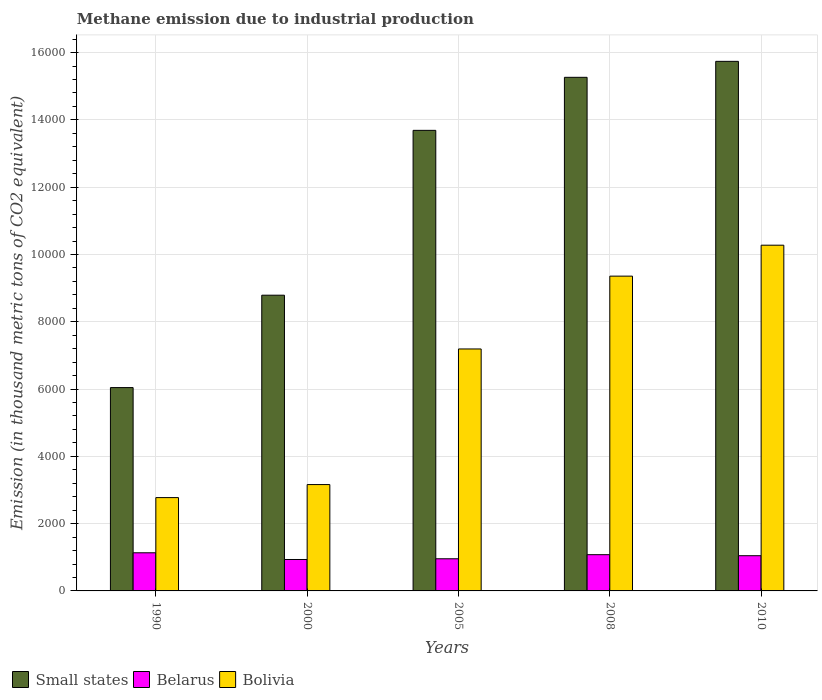How many groups of bars are there?
Give a very brief answer. 5. Are the number of bars per tick equal to the number of legend labels?
Your answer should be compact. Yes. Are the number of bars on each tick of the X-axis equal?
Your answer should be very brief. Yes. How many bars are there on the 2nd tick from the left?
Provide a succinct answer. 3. What is the label of the 1st group of bars from the left?
Offer a terse response. 1990. What is the amount of methane emitted in Belarus in 2010?
Offer a very short reply. 1046.7. Across all years, what is the maximum amount of methane emitted in Small states?
Provide a short and direct response. 1.57e+04. Across all years, what is the minimum amount of methane emitted in Small states?
Give a very brief answer. 6043.6. In which year was the amount of methane emitted in Belarus maximum?
Offer a terse response. 1990. In which year was the amount of methane emitted in Bolivia minimum?
Your answer should be compact. 1990. What is the total amount of methane emitted in Small states in the graph?
Your answer should be very brief. 5.95e+04. What is the difference between the amount of methane emitted in Bolivia in 2008 and that in 2010?
Offer a terse response. -919.7. What is the difference between the amount of methane emitted in Bolivia in 2008 and the amount of methane emitted in Belarus in 2000?
Your answer should be very brief. 8422.1. What is the average amount of methane emitted in Small states per year?
Give a very brief answer. 1.19e+04. In the year 2000, what is the difference between the amount of methane emitted in Small states and amount of methane emitted in Bolivia?
Offer a terse response. 5629.1. What is the ratio of the amount of methane emitted in Belarus in 1990 to that in 2010?
Make the answer very short. 1.08. Is the difference between the amount of methane emitted in Small states in 2005 and 2008 greater than the difference between the amount of methane emitted in Bolivia in 2005 and 2008?
Offer a terse response. Yes. What is the difference between the highest and the second highest amount of methane emitted in Small states?
Your answer should be compact. 474.8. What is the difference between the highest and the lowest amount of methane emitted in Small states?
Offer a very short reply. 9696.7. In how many years, is the amount of methane emitted in Belarus greater than the average amount of methane emitted in Belarus taken over all years?
Offer a terse response. 3. What does the 2nd bar from the left in 1990 represents?
Keep it short and to the point. Belarus. Is it the case that in every year, the sum of the amount of methane emitted in Belarus and amount of methane emitted in Small states is greater than the amount of methane emitted in Bolivia?
Offer a terse response. Yes. How many bars are there?
Make the answer very short. 15. What is the difference between two consecutive major ticks on the Y-axis?
Your answer should be compact. 2000. Does the graph contain grids?
Ensure brevity in your answer.  Yes. How are the legend labels stacked?
Make the answer very short. Horizontal. What is the title of the graph?
Keep it short and to the point. Methane emission due to industrial production. Does "Mexico" appear as one of the legend labels in the graph?
Offer a terse response. No. What is the label or title of the X-axis?
Ensure brevity in your answer.  Years. What is the label or title of the Y-axis?
Provide a short and direct response. Emission (in thousand metric tons of CO2 equivalent). What is the Emission (in thousand metric tons of CO2 equivalent) in Small states in 1990?
Provide a succinct answer. 6043.6. What is the Emission (in thousand metric tons of CO2 equivalent) of Belarus in 1990?
Offer a very short reply. 1133.2. What is the Emission (in thousand metric tons of CO2 equivalent) in Bolivia in 1990?
Keep it short and to the point. 2773.8. What is the Emission (in thousand metric tons of CO2 equivalent) in Small states in 2000?
Offer a terse response. 8790. What is the Emission (in thousand metric tons of CO2 equivalent) of Belarus in 2000?
Give a very brief answer. 934.2. What is the Emission (in thousand metric tons of CO2 equivalent) in Bolivia in 2000?
Offer a terse response. 3160.9. What is the Emission (in thousand metric tons of CO2 equivalent) of Small states in 2005?
Keep it short and to the point. 1.37e+04. What is the Emission (in thousand metric tons of CO2 equivalent) of Belarus in 2005?
Offer a terse response. 955.3. What is the Emission (in thousand metric tons of CO2 equivalent) of Bolivia in 2005?
Offer a very short reply. 7191.7. What is the Emission (in thousand metric tons of CO2 equivalent) in Small states in 2008?
Offer a very short reply. 1.53e+04. What is the Emission (in thousand metric tons of CO2 equivalent) in Belarus in 2008?
Offer a terse response. 1077.2. What is the Emission (in thousand metric tons of CO2 equivalent) of Bolivia in 2008?
Make the answer very short. 9356.3. What is the Emission (in thousand metric tons of CO2 equivalent) of Small states in 2010?
Make the answer very short. 1.57e+04. What is the Emission (in thousand metric tons of CO2 equivalent) of Belarus in 2010?
Keep it short and to the point. 1046.7. What is the Emission (in thousand metric tons of CO2 equivalent) of Bolivia in 2010?
Provide a succinct answer. 1.03e+04. Across all years, what is the maximum Emission (in thousand metric tons of CO2 equivalent) of Small states?
Offer a very short reply. 1.57e+04. Across all years, what is the maximum Emission (in thousand metric tons of CO2 equivalent) in Belarus?
Your response must be concise. 1133.2. Across all years, what is the maximum Emission (in thousand metric tons of CO2 equivalent) in Bolivia?
Your answer should be compact. 1.03e+04. Across all years, what is the minimum Emission (in thousand metric tons of CO2 equivalent) of Small states?
Offer a very short reply. 6043.6. Across all years, what is the minimum Emission (in thousand metric tons of CO2 equivalent) of Belarus?
Provide a succinct answer. 934.2. Across all years, what is the minimum Emission (in thousand metric tons of CO2 equivalent) of Bolivia?
Your answer should be very brief. 2773.8. What is the total Emission (in thousand metric tons of CO2 equivalent) in Small states in the graph?
Your answer should be compact. 5.95e+04. What is the total Emission (in thousand metric tons of CO2 equivalent) of Belarus in the graph?
Make the answer very short. 5146.6. What is the total Emission (in thousand metric tons of CO2 equivalent) in Bolivia in the graph?
Give a very brief answer. 3.28e+04. What is the difference between the Emission (in thousand metric tons of CO2 equivalent) of Small states in 1990 and that in 2000?
Your answer should be compact. -2746.4. What is the difference between the Emission (in thousand metric tons of CO2 equivalent) in Belarus in 1990 and that in 2000?
Make the answer very short. 199. What is the difference between the Emission (in thousand metric tons of CO2 equivalent) in Bolivia in 1990 and that in 2000?
Ensure brevity in your answer.  -387.1. What is the difference between the Emission (in thousand metric tons of CO2 equivalent) of Small states in 1990 and that in 2005?
Your response must be concise. -7645.8. What is the difference between the Emission (in thousand metric tons of CO2 equivalent) of Belarus in 1990 and that in 2005?
Keep it short and to the point. 177.9. What is the difference between the Emission (in thousand metric tons of CO2 equivalent) of Bolivia in 1990 and that in 2005?
Make the answer very short. -4417.9. What is the difference between the Emission (in thousand metric tons of CO2 equivalent) of Small states in 1990 and that in 2008?
Provide a short and direct response. -9221.9. What is the difference between the Emission (in thousand metric tons of CO2 equivalent) of Belarus in 1990 and that in 2008?
Provide a short and direct response. 56. What is the difference between the Emission (in thousand metric tons of CO2 equivalent) of Bolivia in 1990 and that in 2008?
Ensure brevity in your answer.  -6582.5. What is the difference between the Emission (in thousand metric tons of CO2 equivalent) in Small states in 1990 and that in 2010?
Your response must be concise. -9696.7. What is the difference between the Emission (in thousand metric tons of CO2 equivalent) of Belarus in 1990 and that in 2010?
Offer a very short reply. 86.5. What is the difference between the Emission (in thousand metric tons of CO2 equivalent) in Bolivia in 1990 and that in 2010?
Provide a succinct answer. -7502.2. What is the difference between the Emission (in thousand metric tons of CO2 equivalent) of Small states in 2000 and that in 2005?
Your answer should be very brief. -4899.4. What is the difference between the Emission (in thousand metric tons of CO2 equivalent) of Belarus in 2000 and that in 2005?
Provide a short and direct response. -21.1. What is the difference between the Emission (in thousand metric tons of CO2 equivalent) of Bolivia in 2000 and that in 2005?
Make the answer very short. -4030.8. What is the difference between the Emission (in thousand metric tons of CO2 equivalent) of Small states in 2000 and that in 2008?
Your response must be concise. -6475.5. What is the difference between the Emission (in thousand metric tons of CO2 equivalent) in Belarus in 2000 and that in 2008?
Keep it short and to the point. -143. What is the difference between the Emission (in thousand metric tons of CO2 equivalent) of Bolivia in 2000 and that in 2008?
Offer a very short reply. -6195.4. What is the difference between the Emission (in thousand metric tons of CO2 equivalent) of Small states in 2000 and that in 2010?
Your answer should be compact. -6950.3. What is the difference between the Emission (in thousand metric tons of CO2 equivalent) in Belarus in 2000 and that in 2010?
Offer a terse response. -112.5. What is the difference between the Emission (in thousand metric tons of CO2 equivalent) of Bolivia in 2000 and that in 2010?
Your answer should be very brief. -7115.1. What is the difference between the Emission (in thousand metric tons of CO2 equivalent) of Small states in 2005 and that in 2008?
Keep it short and to the point. -1576.1. What is the difference between the Emission (in thousand metric tons of CO2 equivalent) of Belarus in 2005 and that in 2008?
Provide a succinct answer. -121.9. What is the difference between the Emission (in thousand metric tons of CO2 equivalent) of Bolivia in 2005 and that in 2008?
Keep it short and to the point. -2164.6. What is the difference between the Emission (in thousand metric tons of CO2 equivalent) of Small states in 2005 and that in 2010?
Give a very brief answer. -2050.9. What is the difference between the Emission (in thousand metric tons of CO2 equivalent) of Belarus in 2005 and that in 2010?
Make the answer very short. -91.4. What is the difference between the Emission (in thousand metric tons of CO2 equivalent) in Bolivia in 2005 and that in 2010?
Keep it short and to the point. -3084.3. What is the difference between the Emission (in thousand metric tons of CO2 equivalent) of Small states in 2008 and that in 2010?
Offer a terse response. -474.8. What is the difference between the Emission (in thousand metric tons of CO2 equivalent) in Belarus in 2008 and that in 2010?
Provide a short and direct response. 30.5. What is the difference between the Emission (in thousand metric tons of CO2 equivalent) of Bolivia in 2008 and that in 2010?
Make the answer very short. -919.7. What is the difference between the Emission (in thousand metric tons of CO2 equivalent) of Small states in 1990 and the Emission (in thousand metric tons of CO2 equivalent) of Belarus in 2000?
Give a very brief answer. 5109.4. What is the difference between the Emission (in thousand metric tons of CO2 equivalent) of Small states in 1990 and the Emission (in thousand metric tons of CO2 equivalent) of Bolivia in 2000?
Provide a short and direct response. 2882.7. What is the difference between the Emission (in thousand metric tons of CO2 equivalent) in Belarus in 1990 and the Emission (in thousand metric tons of CO2 equivalent) in Bolivia in 2000?
Offer a terse response. -2027.7. What is the difference between the Emission (in thousand metric tons of CO2 equivalent) in Small states in 1990 and the Emission (in thousand metric tons of CO2 equivalent) in Belarus in 2005?
Your response must be concise. 5088.3. What is the difference between the Emission (in thousand metric tons of CO2 equivalent) of Small states in 1990 and the Emission (in thousand metric tons of CO2 equivalent) of Bolivia in 2005?
Keep it short and to the point. -1148.1. What is the difference between the Emission (in thousand metric tons of CO2 equivalent) of Belarus in 1990 and the Emission (in thousand metric tons of CO2 equivalent) of Bolivia in 2005?
Make the answer very short. -6058.5. What is the difference between the Emission (in thousand metric tons of CO2 equivalent) of Small states in 1990 and the Emission (in thousand metric tons of CO2 equivalent) of Belarus in 2008?
Provide a succinct answer. 4966.4. What is the difference between the Emission (in thousand metric tons of CO2 equivalent) in Small states in 1990 and the Emission (in thousand metric tons of CO2 equivalent) in Bolivia in 2008?
Ensure brevity in your answer.  -3312.7. What is the difference between the Emission (in thousand metric tons of CO2 equivalent) of Belarus in 1990 and the Emission (in thousand metric tons of CO2 equivalent) of Bolivia in 2008?
Give a very brief answer. -8223.1. What is the difference between the Emission (in thousand metric tons of CO2 equivalent) of Small states in 1990 and the Emission (in thousand metric tons of CO2 equivalent) of Belarus in 2010?
Provide a succinct answer. 4996.9. What is the difference between the Emission (in thousand metric tons of CO2 equivalent) of Small states in 1990 and the Emission (in thousand metric tons of CO2 equivalent) of Bolivia in 2010?
Your answer should be very brief. -4232.4. What is the difference between the Emission (in thousand metric tons of CO2 equivalent) of Belarus in 1990 and the Emission (in thousand metric tons of CO2 equivalent) of Bolivia in 2010?
Offer a very short reply. -9142.8. What is the difference between the Emission (in thousand metric tons of CO2 equivalent) of Small states in 2000 and the Emission (in thousand metric tons of CO2 equivalent) of Belarus in 2005?
Offer a very short reply. 7834.7. What is the difference between the Emission (in thousand metric tons of CO2 equivalent) of Small states in 2000 and the Emission (in thousand metric tons of CO2 equivalent) of Bolivia in 2005?
Provide a short and direct response. 1598.3. What is the difference between the Emission (in thousand metric tons of CO2 equivalent) of Belarus in 2000 and the Emission (in thousand metric tons of CO2 equivalent) of Bolivia in 2005?
Your answer should be compact. -6257.5. What is the difference between the Emission (in thousand metric tons of CO2 equivalent) in Small states in 2000 and the Emission (in thousand metric tons of CO2 equivalent) in Belarus in 2008?
Your answer should be very brief. 7712.8. What is the difference between the Emission (in thousand metric tons of CO2 equivalent) in Small states in 2000 and the Emission (in thousand metric tons of CO2 equivalent) in Bolivia in 2008?
Your response must be concise. -566.3. What is the difference between the Emission (in thousand metric tons of CO2 equivalent) in Belarus in 2000 and the Emission (in thousand metric tons of CO2 equivalent) in Bolivia in 2008?
Keep it short and to the point. -8422.1. What is the difference between the Emission (in thousand metric tons of CO2 equivalent) of Small states in 2000 and the Emission (in thousand metric tons of CO2 equivalent) of Belarus in 2010?
Give a very brief answer. 7743.3. What is the difference between the Emission (in thousand metric tons of CO2 equivalent) of Small states in 2000 and the Emission (in thousand metric tons of CO2 equivalent) of Bolivia in 2010?
Provide a short and direct response. -1486. What is the difference between the Emission (in thousand metric tons of CO2 equivalent) of Belarus in 2000 and the Emission (in thousand metric tons of CO2 equivalent) of Bolivia in 2010?
Keep it short and to the point. -9341.8. What is the difference between the Emission (in thousand metric tons of CO2 equivalent) of Small states in 2005 and the Emission (in thousand metric tons of CO2 equivalent) of Belarus in 2008?
Ensure brevity in your answer.  1.26e+04. What is the difference between the Emission (in thousand metric tons of CO2 equivalent) in Small states in 2005 and the Emission (in thousand metric tons of CO2 equivalent) in Bolivia in 2008?
Provide a succinct answer. 4333.1. What is the difference between the Emission (in thousand metric tons of CO2 equivalent) in Belarus in 2005 and the Emission (in thousand metric tons of CO2 equivalent) in Bolivia in 2008?
Provide a short and direct response. -8401. What is the difference between the Emission (in thousand metric tons of CO2 equivalent) of Small states in 2005 and the Emission (in thousand metric tons of CO2 equivalent) of Belarus in 2010?
Your response must be concise. 1.26e+04. What is the difference between the Emission (in thousand metric tons of CO2 equivalent) in Small states in 2005 and the Emission (in thousand metric tons of CO2 equivalent) in Bolivia in 2010?
Offer a very short reply. 3413.4. What is the difference between the Emission (in thousand metric tons of CO2 equivalent) of Belarus in 2005 and the Emission (in thousand metric tons of CO2 equivalent) of Bolivia in 2010?
Your response must be concise. -9320.7. What is the difference between the Emission (in thousand metric tons of CO2 equivalent) in Small states in 2008 and the Emission (in thousand metric tons of CO2 equivalent) in Belarus in 2010?
Provide a short and direct response. 1.42e+04. What is the difference between the Emission (in thousand metric tons of CO2 equivalent) of Small states in 2008 and the Emission (in thousand metric tons of CO2 equivalent) of Bolivia in 2010?
Give a very brief answer. 4989.5. What is the difference between the Emission (in thousand metric tons of CO2 equivalent) of Belarus in 2008 and the Emission (in thousand metric tons of CO2 equivalent) of Bolivia in 2010?
Your answer should be compact. -9198.8. What is the average Emission (in thousand metric tons of CO2 equivalent) in Small states per year?
Keep it short and to the point. 1.19e+04. What is the average Emission (in thousand metric tons of CO2 equivalent) in Belarus per year?
Offer a very short reply. 1029.32. What is the average Emission (in thousand metric tons of CO2 equivalent) of Bolivia per year?
Give a very brief answer. 6551.74. In the year 1990, what is the difference between the Emission (in thousand metric tons of CO2 equivalent) of Small states and Emission (in thousand metric tons of CO2 equivalent) of Belarus?
Your response must be concise. 4910.4. In the year 1990, what is the difference between the Emission (in thousand metric tons of CO2 equivalent) of Small states and Emission (in thousand metric tons of CO2 equivalent) of Bolivia?
Keep it short and to the point. 3269.8. In the year 1990, what is the difference between the Emission (in thousand metric tons of CO2 equivalent) of Belarus and Emission (in thousand metric tons of CO2 equivalent) of Bolivia?
Offer a terse response. -1640.6. In the year 2000, what is the difference between the Emission (in thousand metric tons of CO2 equivalent) of Small states and Emission (in thousand metric tons of CO2 equivalent) of Belarus?
Your answer should be very brief. 7855.8. In the year 2000, what is the difference between the Emission (in thousand metric tons of CO2 equivalent) of Small states and Emission (in thousand metric tons of CO2 equivalent) of Bolivia?
Your response must be concise. 5629.1. In the year 2000, what is the difference between the Emission (in thousand metric tons of CO2 equivalent) of Belarus and Emission (in thousand metric tons of CO2 equivalent) of Bolivia?
Your answer should be very brief. -2226.7. In the year 2005, what is the difference between the Emission (in thousand metric tons of CO2 equivalent) in Small states and Emission (in thousand metric tons of CO2 equivalent) in Belarus?
Provide a succinct answer. 1.27e+04. In the year 2005, what is the difference between the Emission (in thousand metric tons of CO2 equivalent) in Small states and Emission (in thousand metric tons of CO2 equivalent) in Bolivia?
Keep it short and to the point. 6497.7. In the year 2005, what is the difference between the Emission (in thousand metric tons of CO2 equivalent) in Belarus and Emission (in thousand metric tons of CO2 equivalent) in Bolivia?
Offer a very short reply. -6236.4. In the year 2008, what is the difference between the Emission (in thousand metric tons of CO2 equivalent) of Small states and Emission (in thousand metric tons of CO2 equivalent) of Belarus?
Provide a short and direct response. 1.42e+04. In the year 2008, what is the difference between the Emission (in thousand metric tons of CO2 equivalent) of Small states and Emission (in thousand metric tons of CO2 equivalent) of Bolivia?
Provide a succinct answer. 5909.2. In the year 2008, what is the difference between the Emission (in thousand metric tons of CO2 equivalent) of Belarus and Emission (in thousand metric tons of CO2 equivalent) of Bolivia?
Provide a succinct answer. -8279.1. In the year 2010, what is the difference between the Emission (in thousand metric tons of CO2 equivalent) of Small states and Emission (in thousand metric tons of CO2 equivalent) of Belarus?
Your answer should be compact. 1.47e+04. In the year 2010, what is the difference between the Emission (in thousand metric tons of CO2 equivalent) of Small states and Emission (in thousand metric tons of CO2 equivalent) of Bolivia?
Your answer should be very brief. 5464.3. In the year 2010, what is the difference between the Emission (in thousand metric tons of CO2 equivalent) of Belarus and Emission (in thousand metric tons of CO2 equivalent) of Bolivia?
Keep it short and to the point. -9229.3. What is the ratio of the Emission (in thousand metric tons of CO2 equivalent) of Small states in 1990 to that in 2000?
Provide a succinct answer. 0.69. What is the ratio of the Emission (in thousand metric tons of CO2 equivalent) in Belarus in 1990 to that in 2000?
Keep it short and to the point. 1.21. What is the ratio of the Emission (in thousand metric tons of CO2 equivalent) of Bolivia in 1990 to that in 2000?
Offer a very short reply. 0.88. What is the ratio of the Emission (in thousand metric tons of CO2 equivalent) of Small states in 1990 to that in 2005?
Offer a terse response. 0.44. What is the ratio of the Emission (in thousand metric tons of CO2 equivalent) of Belarus in 1990 to that in 2005?
Provide a succinct answer. 1.19. What is the ratio of the Emission (in thousand metric tons of CO2 equivalent) in Bolivia in 1990 to that in 2005?
Make the answer very short. 0.39. What is the ratio of the Emission (in thousand metric tons of CO2 equivalent) of Small states in 1990 to that in 2008?
Offer a very short reply. 0.4. What is the ratio of the Emission (in thousand metric tons of CO2 equivalent) in Belarus in 1990 to that in 2008?
Make the answer very short. 1.05. What is the ratio of the Emission (in thousand metric tons of CO2 equivalent) in Bolivia in 1990 to that in 2008?
Offer a terse response. 0.3. What is the ratio of the Emission (in thousand metric tons of CO2 equivalent) in Small states in 1990 to that in 2010?
Provide a succinct answer. 0.38. What is the ratio of the Emission (in thousand metric tons of CO2 equivalent) in Belarus in 1990 to that in 2010?
Your answer should be very brief. 1.08. What is the ratio of the Emission (in thousand metric tons of CO2 equivalent) of Bolivia in 1990 to that in 2010?
Your answer should be compact. 0.27. What is the ratio of the Emission (in thousand metric tons of CO2 equivalent) of Small states in 2000 to that in 2005?
Your response must be concise. 0.64. What is the ratio of the Emission (in thousand metric tons of CO2 equivalent) in Belarus in 2000 to that in 2005?
Give a very brief answer. 0.98. What is the ratio of the Emission (in thousand metric tons of CO2 equivalent) in Bolivia in 2000 to that in 2005?
Make the answer very short. 0.44. What is the ratio of the Emission (in thousand metric tons of CO2 equivalent) in Small states in 2000 to that in 2008?
Your response must be concise. 0.58. What is the ratio of the Emission (in thousand metric tons of CO2 equivalent) of Belarus in 2000 to that in 2008?
Your answer should be compact. 0.87. What is the ratio of the Emission (in thousand metric tons of CO2 equivalent) in Bolivia in 2000 to that in 2008?
Offer a terse response. 0.34. What is the ratio of the Emission (in thousand metric tons of CO2 equivalent) of Small states in 2000 to that in 2010?
Provide a short and direct response. 0.56. What is the ratio of the Emission (in thousand metric tons of CO2 equivalent) in Belarus in 2000 to that in 2010?
Ensure brevity in your answer.  0.89. What is the ratio of the Emission (in thousand metric tons of CO2 equivalent) of Bolivia in 2000 to that in 2010?
Keep it short and to the point. 0.31. What is the ratio of the Emission (in thousand metric tons of CO2 equivalent) of Small states in 2005 to that in 2008?
Your answer should be compact. 0.9. What is the ratio of the Emission (in thousand metric tons of CO2 equivalent) in Belarus in 2005 to that in 2008?
Keep it short and to the point. 0.89. What is the ratio of the Emission (in thousand metric tons of CO2 equivalent) of Bolivia in 2005 to that in 2008?
Your response must be concise. 0.77. What is the ratio of the Emission (in thousand metric tons of CO2 equivalent) in Small states in 2005 to that in 2010?
Offer a very short reply. 0.87. What is the ratio of the Emission (in thousand metric tons of CO2 equivalent) of Belarus in 2005 to that in 2010?
Your answer should be very brief. 0.91. What is the ratio of the Emission (in thousand metric tons of CO2 equivalent) in Bolivia in 2005 to that in 2010?
Offer a terse response. 0.7. What is the ratio of the Emission (in thousand metric tons of CO2 equivalent) of Small states in 2008 to that in 2010?
Provide a short and direct response. 0.97. What is the ratio of the Emission (in thousand metric tons of CO2 equivalent) in Belarus in 2008 to that in 2010?
Offer a very short reply. 1.03. What is the ratio of the Emission (in thousand metric tons of CO2 equivalent) of Bolivia in 2008 to that in 2010?
Provide a short and direct response. 0.91. What is the difference between the highest and the second highest Emission (in thousand metric tons of CO2 equivalent) in Small states?
Give a very brief answer. 474.8. What is the difference between the highest and the second highest Emission (in thousand metric tons of CO2 equivalent) of Bolivia?
Make the answer very short. 919.7. What is the difference between the highest and the lowest Emission (in thousand metric tons of CO2 equivalent) in Small states?
Provide a succinct answer. 9696.7. What is the difference between the highest and the lowest Emission (in thousand metric tons of CO2 equivalent) in Belarus?
Give a very brief answer. 199. What is the difference between the highest and the lowest Emission (in thousand metric tons of CO2 equivalent) of Bolivia?
Offer a very short reply. 7502.2. 